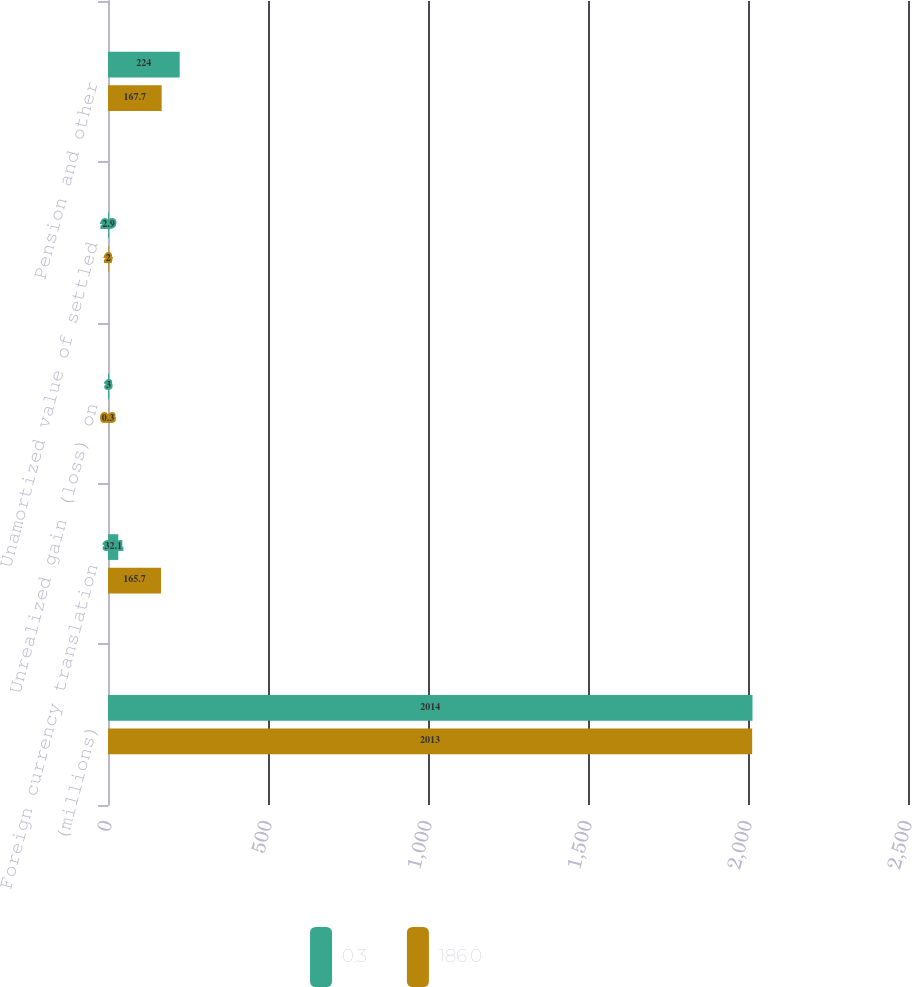Convert chart to OTSL. <chart><loc_0><loc_0><loc_500><loc_500><stacked_bar_chart><ecel><fcel>(millions)<fcel>Foreign currency translation<fcel>Unrealized gain (loss) on<fcel>Unamortized value of settled<fcel>Pension and other<nl><fcel>0.3<fcel>2014<fcel>32.1<fcel>3<fcel>2.9<fcel>224<nl><fcel>186<fcel>2013<fcel>165.7<fcel>0.3<fcel>2<fcel>167.7<nl></chart> 